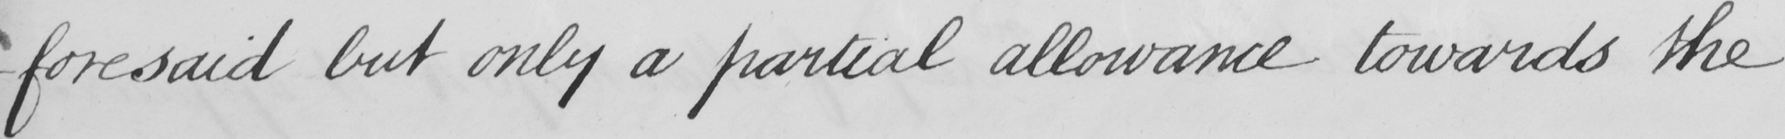Please transcribe the handwritten text in this image. -foresaid but only a partial allowance towards the 